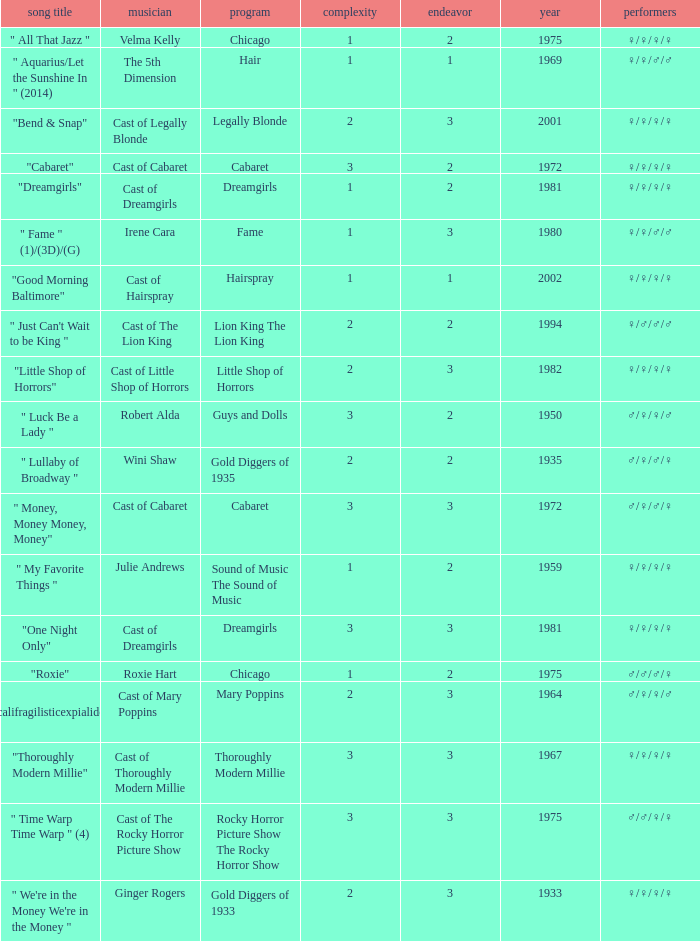What show featured the song "little shop of horrors"? Little Shop of Horrors. 